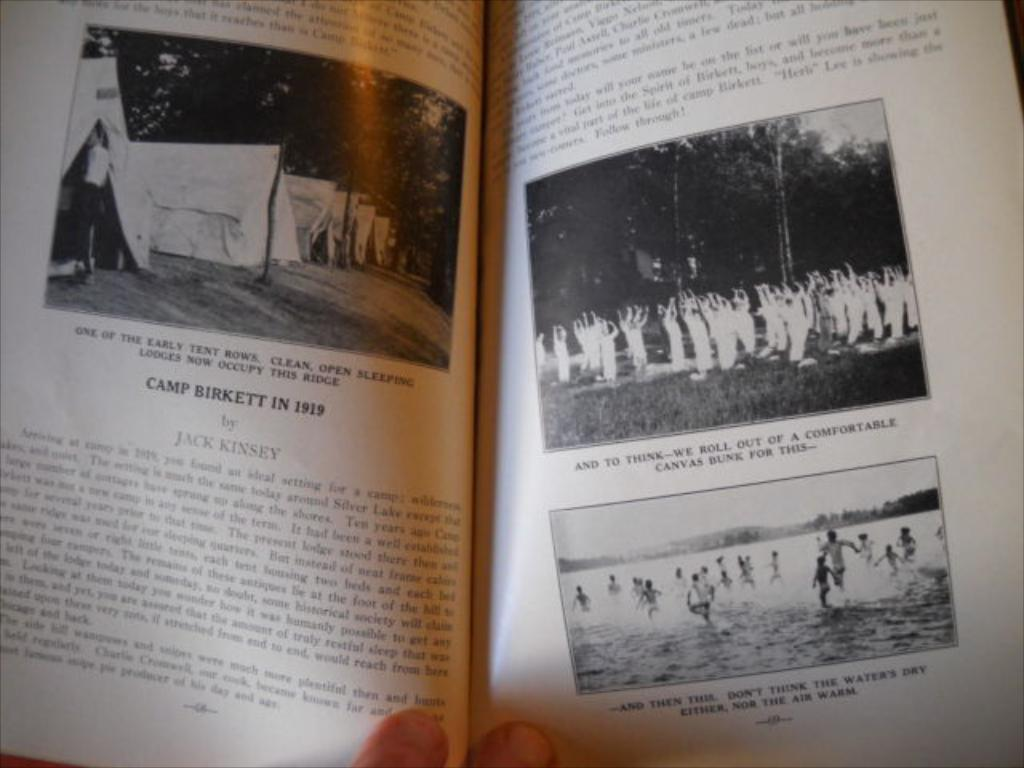<image>
Create a compact narrative representing the image presented. Pages from a book show the details of Camp Birkett in 1919. 